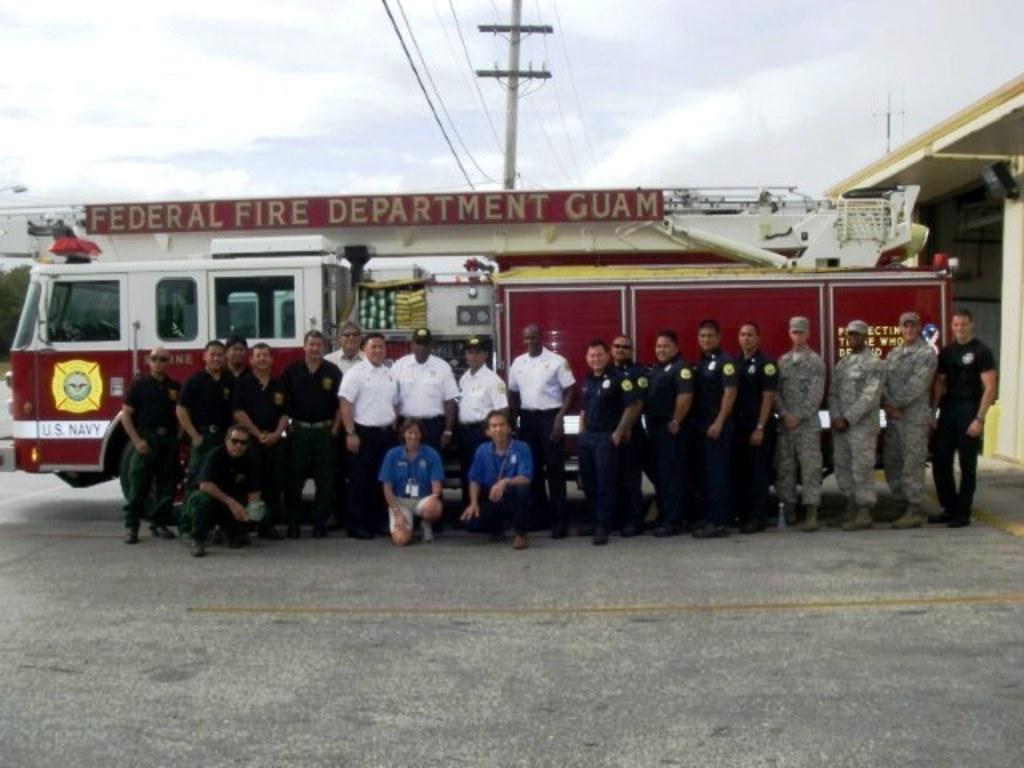Can you describe this image briefly? In this picture I can see the path in front, on which I can see number of people and behind them I can see a fire engine and I see something is written on it. In the background I can see a pole, few wires, a building and the sky. 